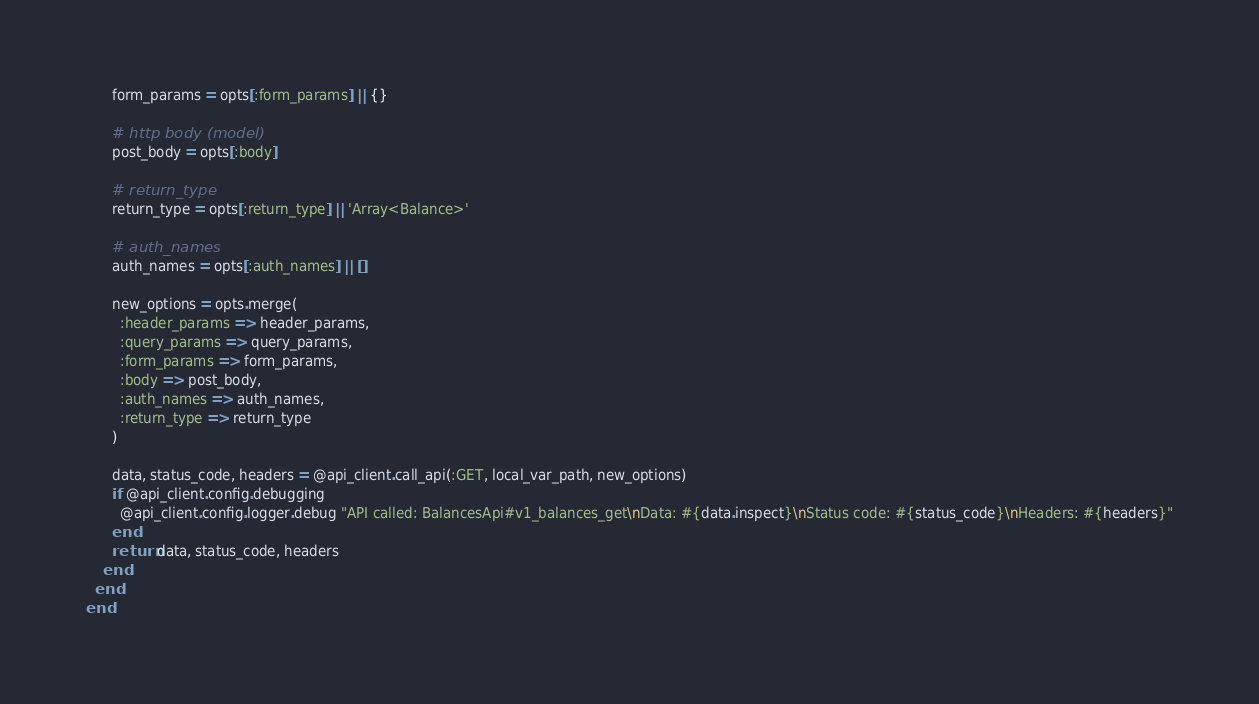<code> <loc_0><loc_0><loc_500><loc_500><_Ruby_>      form_params = opts[:form_params] || {}

      # http body (model)
      post_body = opts[:body] 

      # return_type
      return_type = opts[:return_type] || 'Array<Balance>' 

      # auth_names
      auth_names = opts[:auth_names] || []

      new_options = opts.merge(
        :header_params => header_params,
        :query_params => query_params,
        :form_params => form_params,
        :body => post_body,
        :auth_names => auth_names,
        :return_type => return_type
      )

      data, status_code, headers = @api_client.call_api(:GET, local_var_path, new_options)
      if @api_client.config.debugging
        @api_client.config.logger.debug "API called: BalancesApi#v1_balances_get\nData: #{data.inspect}\nStatus code: #{status_code}\nHeaders: #{headers}"
      end
      return data, status_code, headers
    end
  end
end
</code> 